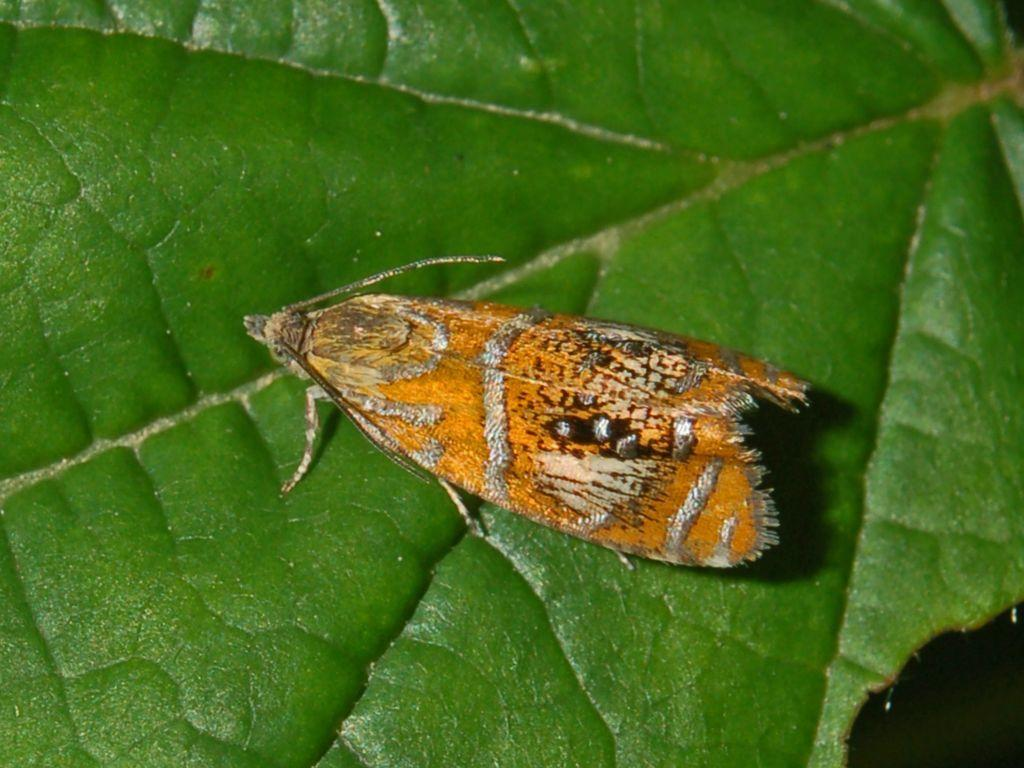What is the main subject of the image? The main subject of the image is a fly on a leaf. Where is the fly located in relation to the leaf? The fly is located in the center of the image. What type of joke is the fly telling in the image? There is no indication in the image that the fly is telling a joke, as flies do not have the ability to communicate through humor. 